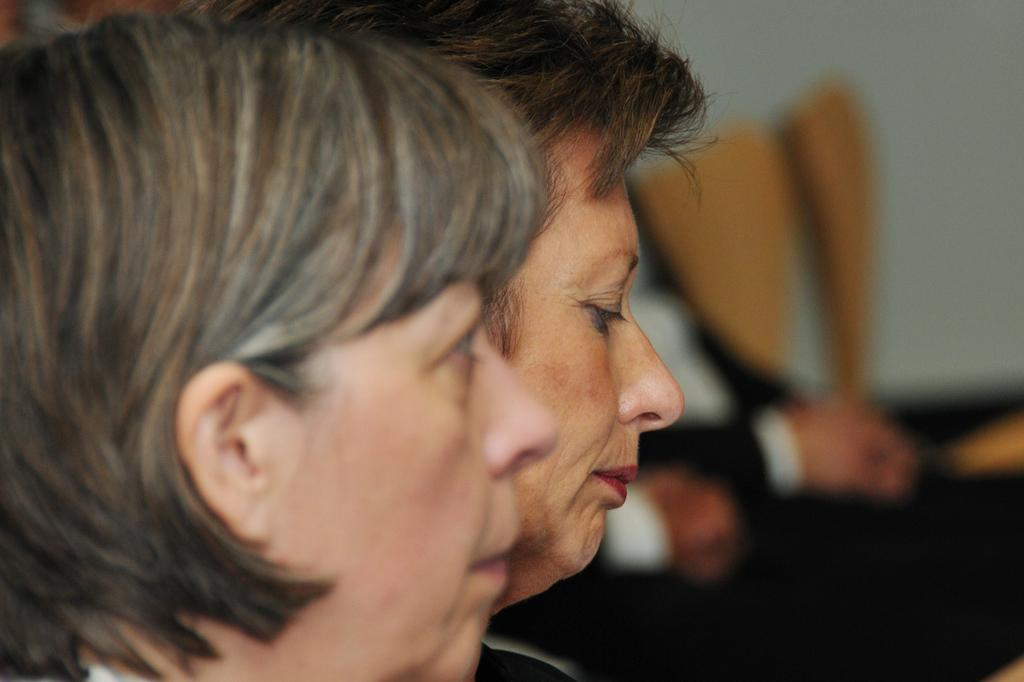What are the women in the image doing? The women in the image are seated on chairs. Are there any other people visible in the image? Yes, there are people on the side in the image. How many empty chairs are there in the image? There are empty chairs in the image. What type of jewel is being discussed by the women in the image? There is no indication in the image that the women are discussing a jewel, so it cannot be determined from the picture. 